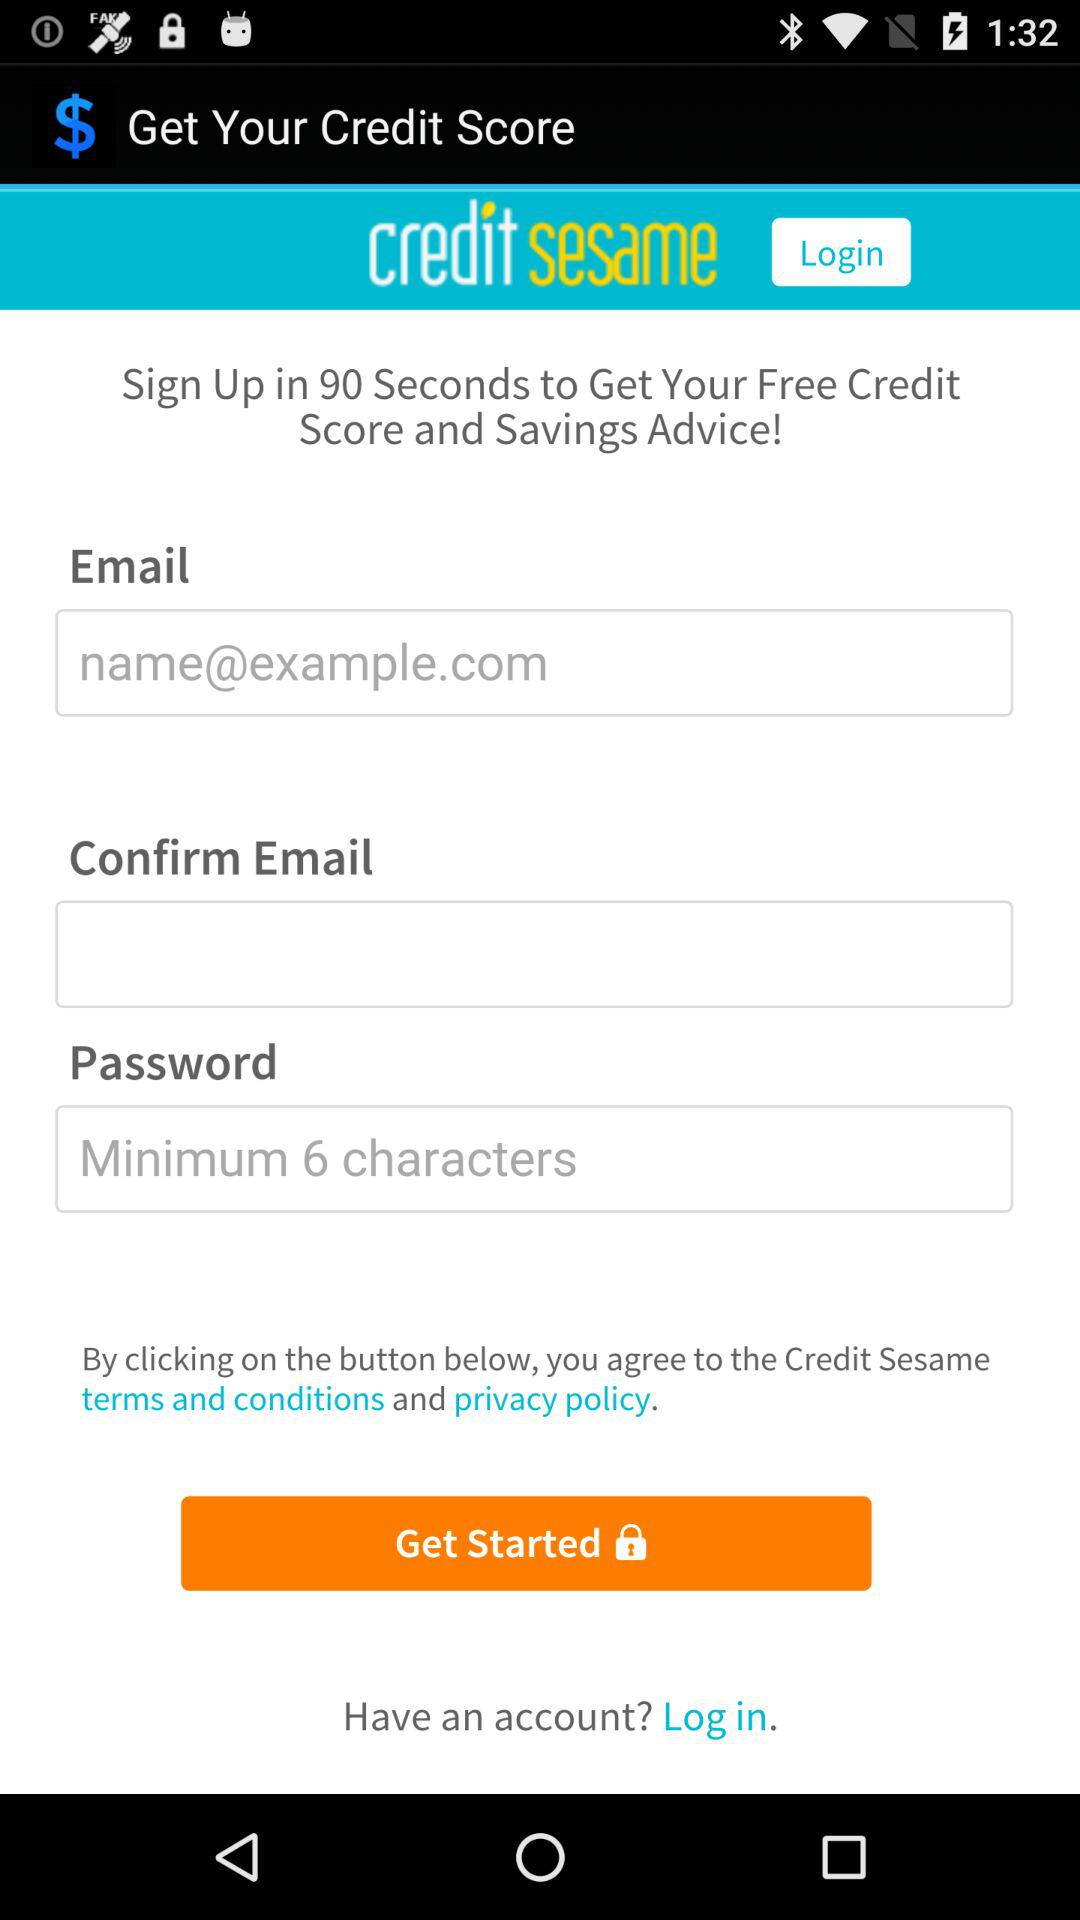What is the given email address? The given email address is name@example.com. 